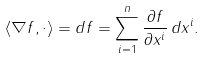Convert formula to latex. <formula><loc_0><loc_0><loc_500><loc_500>\langle \nabla f , \cdot \rangle = d f = \sum _ { i = 1 } ^ { n } { \frac { \partial f } { \partial x ^ { i } } } \, d x ^ { i } .</formula> 